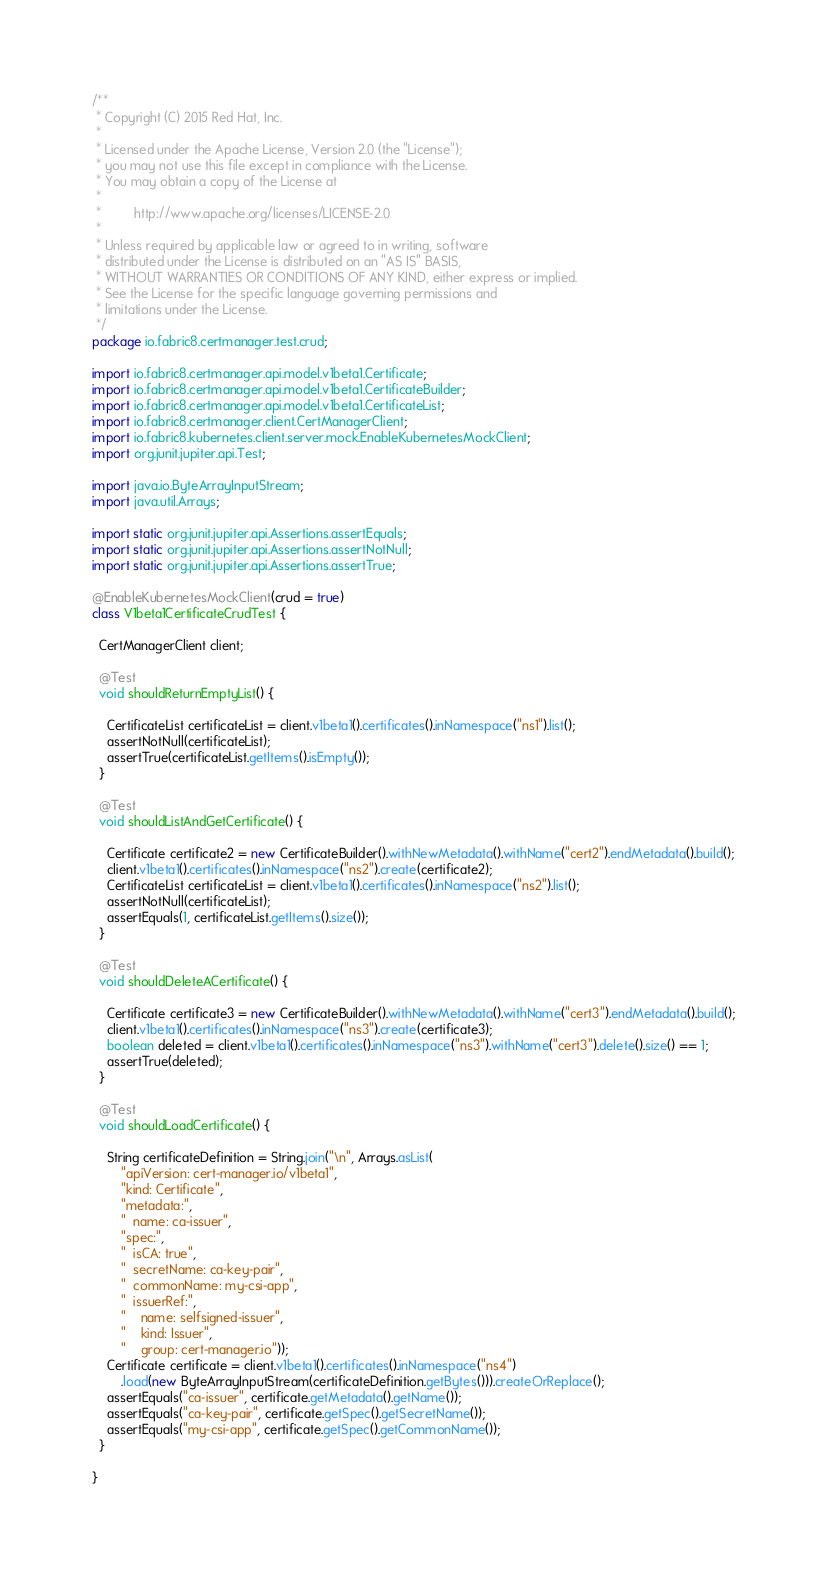<code> <loc_0><loc_0><loc_500><loc_500><_Java_>/**
 * Copyright (C) 2015 Red Hat, Inc.
 *
 * Licensed under the Apache License, Version 2.0 (the "License");
 * you may not use this file except in compliance with the License.
 * You may obtain a copy of the License at
 *
 *         http://www.apache.org/licenses/LICENSE-2.0
 *
 * Unless required by applicable law or agreed to in writing, software
 * distributed under the License is distributed on an "AS IS" BASIS,
 * WITHOUT WARRANTIES OR CONDITIONS OF ANY KIND, either express or implied.
 * See the License for the specific language governing permissions and
 * limitations under the License.
 */
package io.fabric8.certmanager.test.crud;

import io.fabric8.certmanager.api.model.v1beta1.Certificate;
import io.fabric8.certmanager.api.model.v1beta1.CertificateBuilder;
import io.fabric8.certmanager.api.model.v1beta1.CertificateList;
import io.fabric8.certmanager.client.CertManagerClient;
import io.fabric8.kubernetes.client.server.mock.EnableKubernetesMockClient;
import org.junit.jupiter.api.Test;

import java.io.ByteArrayInputStream;
import java.util.Arrays;

import static org.junit.jupiter.api.Assertions.assertEquals;
import static org.junit.jupiter.api.Assertions.assertNotNull;
import static org.junit.jupiter.api.Assertions.assertTrue;

@EnableKubernetesMockClient(crud = true)
class V1beta1CertificateCrudTest {

  CertManagerClient client;

  @Test
  void shouldReturnEmptyList() {

    CertificateList certificateList = client.v1beta1().certificates().inNamespace("ns1").list();
    assertNotNull(certificateList);
    assertTrue(certificateList.getItems().isEmpty());
  }

  @Test
  void shouldListAndGetCertificate() {

    Certificate certificate2 = new CertificateBuilder().withNewMetadata().withName("cert2").endMetadata().build();
    client.v1beta1().certificates().inNamespace("ns2").create(certificate2);
    CertificateList certificateList = client.v1beta1().certificates().inNamespace("ns2").list();
    assertNotNull(certificateList);
    assertEquals(1, certificateList.getItems().size());
  }

  @Test
  void shouldDeleteACertificate() {

    Certificate certificate3 = new CertificateBuilder().withNewMetadata().withName("cert3").endMetadata().build();
    client.v1beta1().certificates().inNamespace("ns3").create(certificate3);
    boolean deleted = client.v1beta1().certificates().inNamespace("ns3").withName("cert3").delete().size() == 1;
    assertTrue(deleted);
  }

  @Test
  void shouldLoadCertificate() {

    String certificateDefinition = String.join("\n", Arrays.asList(
        "apiVersion: cert-manager.io/v1beta1",
        "kind: Certificate",
        "metadata:",
        "  name: ca-issuer",
        "spec:",
        "  isCA: true",
        "  secretName: ca-key-pair",
        "  commonName: my-csi-app",
        "  issuerRef:",
        "    name: selfsigned-issuer",
        "    kind: Issuer",
        "    group: cert-manager.io"));
    Certificate certificate = client.v1beta1().certificates().inNamespace("ns4")
        .load(new ByteArrayInputStream(certificateDefinition.getBytes())).createOrReplace();
    assertEquals("ca-issuer", certificate.getMetadata().getName());
    assertEquals("ca-key-pair", certificate.getSpec().getSecretName());
    assertEquals("my-csi-app", certificate.getSpec().getCommonName());
  }

}
</code> 